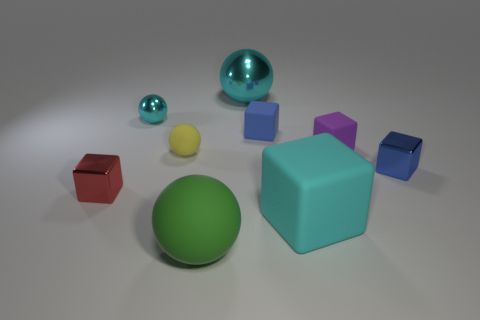Subtract all tiny rubber balls. How many balls are left? 3 Subtract all gray cylinders. How many blue blocks are left? 2 Subtract all blue blocks. How many blocks are left? 3 Add 1 tiny red objects. How many objects exist? 10 Subtract 3 balls. How many balls are left? 1 Subtract all cubes. How many objects are left? 4 Subtract all purple cubes. Subtract all purple spheres. How many cubes are left? 4 Subtract all blue blocks. Subtract all cyan rubber blocks. How many objects are left? 6 Add 4 big objects. How many big objects are left? 7 Add 4 purple rubber things. How many purple rubber things exist? 5 